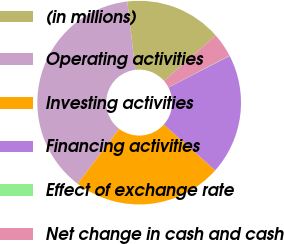<chart> <loc_0><loc_0><loc_500><loc_500><pie_chart><fcel>(in millions)<fcel>Operating activities<fcel>Investing activities<fcel>Financing activities<fcel>Effect of exchange rate<fcel>Net change in cash and cash<nl><fcel>15.4%<fcel>37.81%<fcel>23.73%<fcel>19.18%<fcel>0.05%<fcel>3.83%<nl></chart> 